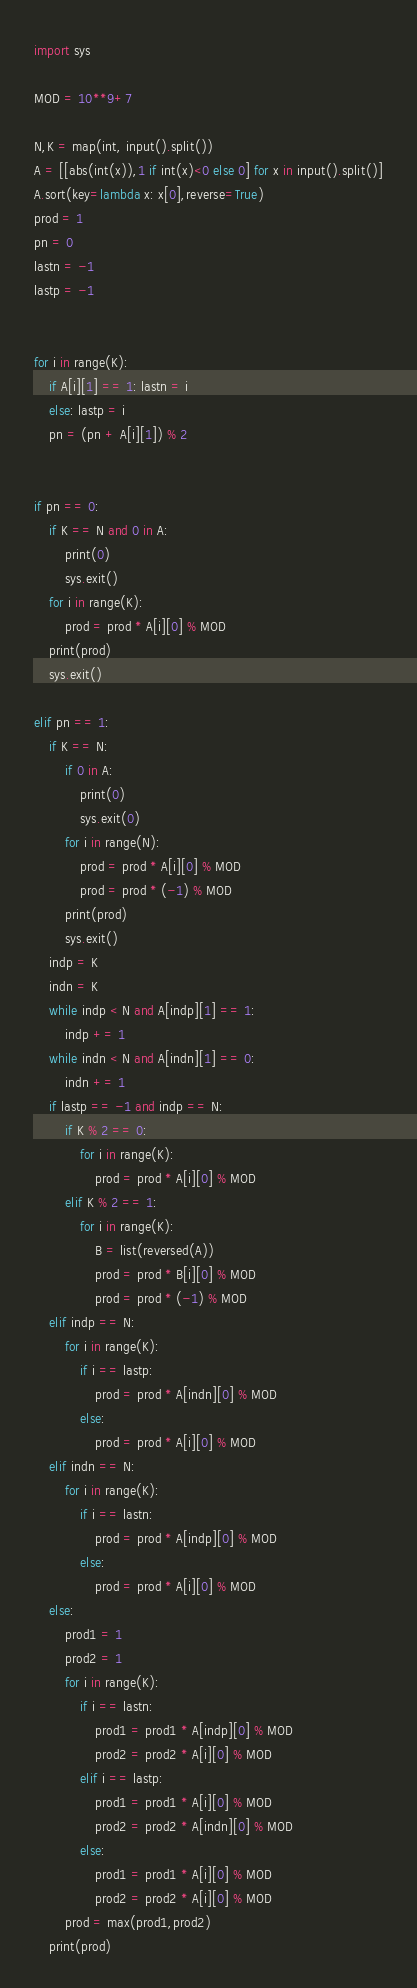Convert code to text. <code><loc_0><loc_0><loc_500><loc_500><_Python_>import sys

MOD = 10**9+7

N,K = map(int, input().split())
A = [[abs(int(x)),1 if int(x)<0 else 0] for x in input().split()]
A.sort(key=lambda x: x[0],reverse=True)
prod = 1
pn = 0
lastn = -1
lastp = -1


for i in range(K):
    if A[i][1] == 1: lastn = i
    else: lastp = i
    pn = (pn + A[i][1]) % 2


if pn == 0:
    if K == N and 0 in A:
        print(0)
        sys.exit()
    for i in range(K):
        prod = prod * A[i][0] % MOD
    print(prod)
    sys.exit()

elif pn == 1:
    if K == N:
        if 0 in A:
            print(0)
            sys.exit(0)
        for i in range(N):
            prod = prod * A[i][0] % MOD
            prod = prod * (-1) % MOD
        print(prod)
        sys.exit()
    indp = K
    indn = K
    while indp < N and A[indp][1] == 1:
        indp += 1
    while indn < N and A[indn][1] == 0:
        indn += 1
    if lastp == -1 and indp == N:
        if K % 2 == 0:
            for i in range(K):
                prod = prod * A[i][0] % MOD
        elif K % 2 == 1:
            for i in range(K):
                B = list(reversed(A))
                prod = prod * B[i][0] % MOD
                prod = prod * (-1) % MOD
    elif indp == N:
        for i in range(K):
            if i == lastp:
                prod = prod * A[indn][0] % MOD
            else:
                prod = prod * A[i][0] % MOD
    elif indn == N:
        for i in range(K):
            if i == lastn:
                prod = prod * A[indp][0] % MOD
            else:
                prod = prod * A[i][0] % MOD
    else:
        prod1 = 1
        prod2 = 1
        for i in range(K):
            if i == lastn:
                prod1 = prod1 * A[indp][0] % MOD
                prod2 = prod2 * A[i][0] % MOD
            elif i == lastp:
                prod1 = prod1 * A[i][0] % MOD
                prod2 = prod2 * A[indn][0] % MOD
            else:
                prod1 = prod1 * A[i][0] % MOD
                prod2 = prod2 * A[i][0] % MOD
        prod = max(prod1,prod2)
    print(prod)</code> 